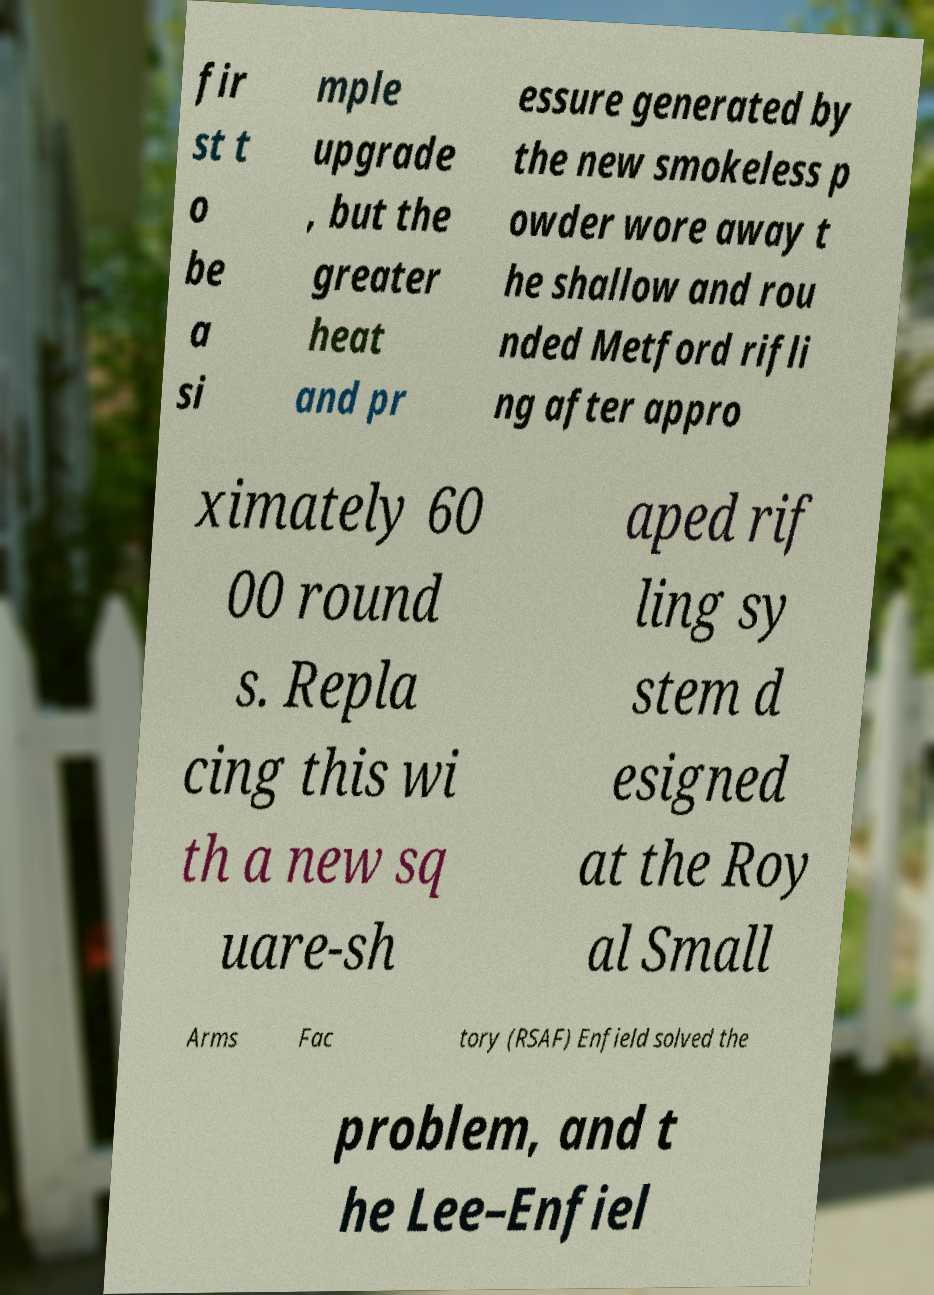Could you extract and type out the text from this image? fir st t o be a si mple upgrade , but the greater heat and pr essure generated by the new smokeless p owder wore away t he shallow and rou nded Metford rifli ng after appro ximately 60 00 round s. Repla cing this wi th a new sq uare-sh aped rif ling sy stem d esigned at the Roy al Small Arms Fac tory (RSAF) Enfield solved the problem, and t he Lee–Enfiel 